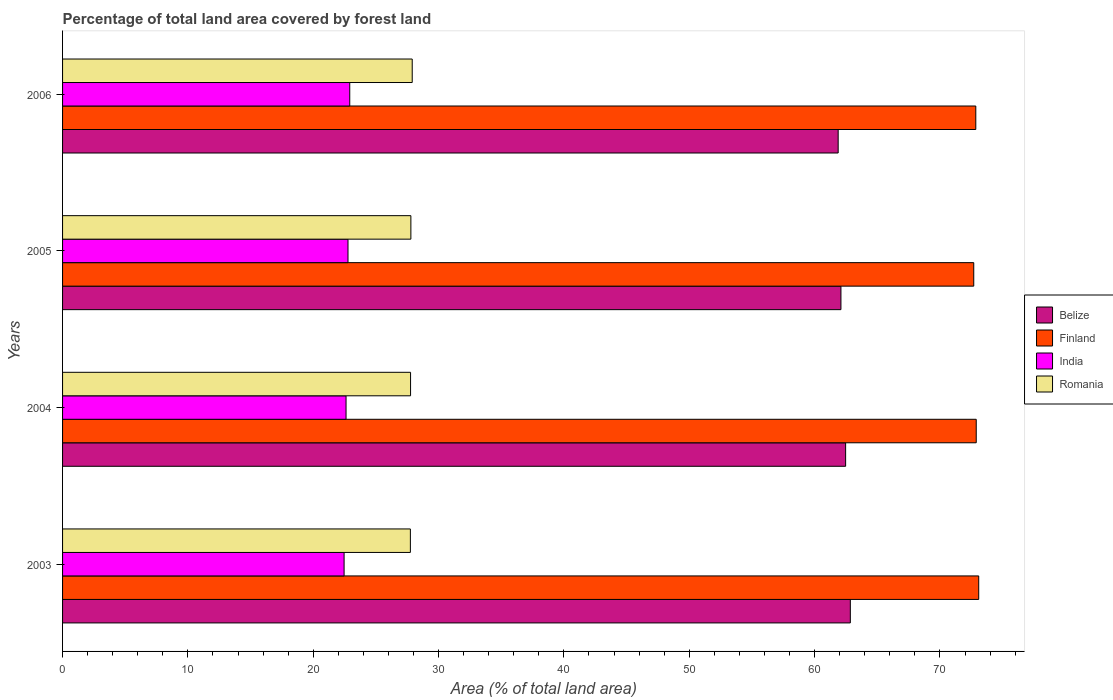How many different coloured bars are there?
Your answer should be very brief. 4. How many groups of bars are there?
Keep it short and to the point. 4. How many bars are there on the 3rd tick from the top?
Offer a very short reply. 4. In how many cases, is the number of bars for a given year not equal to the number of legend labels?
Provide a short and direct response. 0. What is the percentage of forest land in Romania in 2003?
Make the answer very short. 27.75. Across all years, what is the maximum percentage of forest land in Finland?
Ensure brevity in your answer.  73.09. Across all years, what is the minimum percentage of forest land in India?
Your answer should be very brief. 22.46. In which year was the percentage of forest land in Finland maximum?
Your answer should be compact. 2003. What is the total percentage of forest land in Finland in the graph?
Offer a very short reply. 291.55. What is the difference between the percentage of forest land in Finland in 2003 and that in 2005?
Keep it short and to the point. 0.4. What is the difference between the percentage of forest land in India in 2005 and the percentage of forest land in Belize in 2003?
Offer a very short reply. -40.08. What is the average percentage of forest land in Romania per year?
Give a very brief answer. 27.8. In the year 2005, what is the difference between the percentage of forest land in Finland and percentage of forest land in Belize?
Provide a short and direct response. 10.6. In how many years, is the percentage of forest land in Romania greater than 48 %?
Your answer should be compact. 0. What is the ratio of the percentage of forest land in India in 2003 to that in 2006?
Your answer should be very brief. 0.98. Is the difference between the percentage of forest land in Finland in 2003 and 2004 greater than the difference between the percentage of forest land in Belize in 2003 and 2004?
Give a very brief answer. No. What is the difference between the highest and the second highest percentage of forest land in Finland?
Offer a very short reply. 0.2. What is the difference between the highest and the lowest percentage of forest land in Finland?
Keep it short and to the point. 0.4. Is it the case that in every year, the sum of the percentage of forest land in Romania and percentage of forest land in India is greater than the sum of percentage of forest land in Belize and percentage of forest land in Finland?
Provide a succinct answer. No. What does the 4th bar from the top in 2005 represents?
Your response must be concise. Belize. What does the 3rd bar from the bottom in 2005 represents?
Your response must be concise. India. What is the difference between two consecutive major ticks on the X-axis?
Your answer should be compact. 10. Does the graph contain any zero values?
Give a very brief answer. No. Where does the legend appear in the graph?
Your answer should be compact. Center right. How many legend labels are there?
Make the answer very short. 4. How are the legend labels stacked?
Make the answer very short. Vertical. What is the title of the graph?
Provide a short and direct response. Percentage of total land area covered by forest land. What is the label or title of the X-axis?
Keep it short and to the point. Area (% of total land area). What is the Area (% of total land area) of Belize in 2003?
Offer a very short reply. 62.85. What is the Area (% of total land area) in Finland in 2003?
Make the answer very short. 73.09. What is the Area (% of total land area) of India in 2003?
Keep it short and to the point. 22.46. What is the Area (% of total land area) in Romania in 2003?
Give a very brief answer. 27.75. What is the Area (% of total land area) of Belize in 2004?
Provide a short and direct response. 62.48. What is the Area (% of total land area) in Finland in 2004?
Provide a short and direct response. 72.9. What is the Area (% of total land area) in India in 2004?
Offer a very short reply. 22.62. What is the Area (% of total land area) of Romania in 2004?
Provide a succinct answer. 27.77. What is the Area (% of total land area) in Belize in 2005?
Make the answer very short. 62.1. What is the Area (% of total land area) in Finland in 2005?
Make the answer very short. 72.7. What is the Area (% of total land area) in India in 2005?
Keep it short and to the point. 22.77. What is the Area (% of total land area) in Romania in 2005?
Provide a succinct answer. 27.79. What is the Area (% of total land area) of Belize in 2006?
Provide a short and direct response. 61.88. What is the Area (% of total land area) of Finland in 2006?
Ensure brevity in your answer.  72.86. What is the Area (% of total land area) in India in 2006?
Make the answer very short. 22.91. What is the Area (% of total land area) of Romania in 2006?
Your response must be concise. 27.9. Across all years, what is the maximum Area (% of total land area) in Belize?
Your answer should be compact. 62.85. Across all years, what is the maximum Area (% of total land area) in Finland?
Offer a very short reply. 73.09. Across all years, what is the maximum Area (% of total land area) of India?
Ensure brevity in your answer.  22.91. Across all years, what is the maximum Area (% of total land area) of Romania?
Ensure brevity in your answer.  27.9. Across all years, what is the minimum Area (% of total land area) of Belize?
Offer a very short reply. 61.88. Across all years, what is the minimum Area (% of total land area) of Finland?
Make the answer very short. 72.7. Across all years, what is the minimum Area (% of total land area) of India?
Provide a succinct answer. 22.46. Across all years, what is the minimum Area (% of total land area) in Romania?
Ensure brevity in your answer.  27.75. What is the total Area (% of total land area) in Belize in the graph?
Your response must be concise. 249.31. What is the total Area (% of total land area) of Finland in the graph?
Your answer should be very brief. 291.55. What is the total Area (% of total land area) of India in the graph?
Your response must be concise. 90.76. What is the total Area (% of total land area) of Romania in the graph?
Provide a short and direct response. 111.2. What is the difference between the Area (% of total land area) in Belize in 2003 and that in 2004?
Give a very brief answer. 0.38. What is the difference between the Area (% of total land area) of Finland in 2003 and that in 2004?
Provide a succinct answer. 0.2. What is the difference between the Area (% of total land area) of India in 2003 and that in 2004?
Provide a succinct answer. -0.16. What is the difference between the Area (% of total land area) of Romania in 2003 and that in 2004?
Your answer should be compact. -0.02. What is the difference between the Area (% of total land area) of Belize in 2003 and that in 2005?
Provide a short and direct response. 0.75. What is the difference between the Area (% of total land area) in Finland in 2003 and that in 2005?
Make the answer very short. 0.4. What is the difference between the Area (% of total land area) of India in 2003 and that in 2005?
Offer a terse response. -0.31. What is the difference between the Area (% of total land area) of Romania in 2003 and that in 2005?
Keep it short and to the point. -0.04. What is the difference between the Area (% of total land area) in Belize in 2003 and that in 2006?
Provide a succinct answer. 0.97. What is the difference between the Area (% of total land area) of Finland in 2003 and that in 2006?
Your answer should be very brief. 0.23. What is the difference between the Area (% of total land area) of India in 2003 and that in 2006?
Make the answer very short. -0.45. What is the difference between the Area (% of total land area) of Romania in 2003 and that in 2006?
Your response must be concise. -0.15. What is the difference between the Area (% of total land area) of Belize in 2004 and that in 2005?
Provide a short and direct response. 0.37. What is the difference between the Area (% of total land area) of Finland in 2004 and that in 2005?
Provide a short and direct response. 0.2. What is the difference between the Area (% of total land area) in India in 2004 and that in 2005?
Offer a very short reply. -0.16. What is the difference between the Area (% of total land area) of Romania in 2004 and that in 2005?
Ensure brevity in your answer.  -0.02. What is the difference between the Area (% of total land area) in Belize in 2004 and that in 2006?
Your answer should be compact. 0.6. What is the difference between the Area (% of total land area) in Finland in 2004 and that in 2006?
Your answer should be compact. 0.03. What is the difference between the Area (% of total land area) in India in 2004 and that in 2006?
Give a very brief answer. -0.3. What is the difference between the Area (% of total land area) in Romania in 2004 and that in 2006?
Your answer should be compact. -0.13. What is the difference between the Area (% of total land area) of Belize in 2005 and that in 2006?
Your answer should be very brief. 0.22. What is the difference between the Area (% of total land area) in Finland in 2005 and that in 2006?
Make the answer very short. -0.16. What is the difference between the Area (% of total land area) of India in 2005 and that in 2006?
Give a very brief answer. -0.14. What is the difference between the Area (% of total land area) in Romania in 2005 and that in 2006?
Give a very brief answer. -0.11. What is the difference between the Area (% of total land area) of Belize in 2003 and the Area (% of total land area) of Finland in 2004?
Ensure brevity in your answer.  -10.04. What is the difference between the Area (% of total land area) in Belize in 2003 and the Area (% of total land area) in India in 2004?
Offer a terse response. 40.23. What is the difference between the Area (% of total land area) of Belize in 2003 and the Area (% of total land area) of Romania in 2004?
Offer a very short reply. 35.09. What is the difference between the Area (% of total land area) in Finland in 2003 and the Area (% of total land area) in India in 2004?
Offer a very short reply. 50.48. What is the difference between the Area (% of total land area) of Finland in 2003 and the Area (% of total land area) of Romania in 2004?
Offer a very short reply. 45.33. What is the difference between the Area (% of total land area) in India in 2003 and the Area (% of total land area) in Romania in 2004?
Offer a very short reply. -5.3. What is the difference between the Area (% of total land area) in Belize in 2003 and the Area (% of total land area) in Finland in 2005?
Keep it short and to the point. -9.85. What is the difference between the Area (% of total land area) in Belize in 2003 and the Area (% of total land area) in India in 2005?
Your answer should be very brief. 40.08. What is the difference between the Area (% of total land area) in Belize in 2003 and the Area (% of total land area) in Romania in 2005?
Your response must be concise. 35.06. What is the difference between the Area (% of total land area) of Finland in 2003 and the Area (% of total land area) of India in 2005?
Your answer should be very brief. 50.32. What is the difference between the Area (% of total land area) in Finland in 2003 and the Area (% of total land area) in Romania in 2005?
Give a very brief answer. 45.3. What is the difference between the Area (% of total land area) in India in 2003 and the Area (% of total land area) in Romania in 2005?
Your answer should be very brief. -5.33. What is the difference between the Area (% of total land area) in Belize in 2003 and the Area (% of total land area) in Finland in 2006?
Provide a succinct answer. -10.01. What is the difference between the Area (% of total land area) of Belize in 2003 and the Area (% of total land area) of India in 2006?
Provide a succinct answer. 39.94. What is the difference between the Area (% of total land area) in Belize in 2003 and the Area (% of total land area) in Romania in 2006?
Make the answer very short. 34.95. What is the difference between the Area (% of total land area) in Finland in 2003 and the Area (% of total land area) in India in 2006?
Your answer should be very brief. 50.18. What is the difference between the Area (% of total land area) of Finland in 2003 and the Area (% of total land area) of Romania in 2006?
Provide a succinct answer. 45.2. What is the difference between the Area (% of total land area) in India in 2003 and the Area (% of total land area) in Romania in 2006?
Your response must be concise. -5.44. What is the difference between the Area (% of total land area) of Belize in 2004 and the Area (% of total land area) of Finland in 2005?
Offer a very short reply. -10.22. What is the difference between the Area (% of total land area) of Belize in 2004 and the Area (% of total land area) of India in 2005?
Offer a terse response. 39.7. What is the difference between the Area (% of total land area) of Belize in 2004 and the Area (% of total land area) of Romania in 2005?
Provide a succinct answer. 34.69. What is the difference between the Area (% of total land area) in Finland in 2004 and the Area (% of total land area) in India in 2005?
Ensure brevity in your answer.  50.12. What is the difference between the Area (% of total land area) of Finland in 2004 and the Area (% of total land area) of Romania in 2005?
Give a very brief answer. 45.11. What is the difference between the Area (% of total land area) of India in 2004 and the Area (% of total land area) of Romania in 2005?
Keep it short and to the point. -5.17. What is the difference between the Area (% of total land area) in Belize in 2004 and the Area (% of total land area) in Finland in 2006?
Your answer should be compact. -10.39. What is the difference between the Area (% of total land area) in Belize in 2004 and the Area (% of total land area) in India in 2006?
Your answer should be compact. 39.56. What is the difference between the Area (% of total land area) in Belize in 2004 and the Area (% of total land area) in Romania in 2006?
Provide a succinct answer. 34.58. What is the difference between the Area (% of total land area) of Finland in 2004 and the Area (% of total land area) of India in 2006?
Keep it short and to the point. 49.98. What is the difference between the Area (% of total land area) of Finland in 2004 and the Area (% of total land area) of Romania in 2006?
Offer a terse response. 45. What is the difference between the Area (% of total land area) in India in 2004 and the Area (% of total land area) in Romania in 2006?
Your answer should be compact. -5.28. What is the difference between the Area (% of total land area) in Belize in 2005 and the Area (% of total land area) in Finland in 2006?
Keep it short and to the point. -10.76. What is the difference between the Area (% of total land area) of Belize in 2005 and the Area (% of total land area) of India in 2006?
Your answer should be compact. 39.19. What is the difference between the Area (% of total land area) of Belize in 2005 and the Area (% of total land area) of Romania in 2006?
Your answer should be very brief. 34.2. What is the difference between the Area (% of total land area) in Finland in 2005 and the Area (% of total land area) in India in 2006?
Give a very brief answer. 49.78. What is the difference between the Area (% of total land area) in Finland in 2005 and the Area (% of total land area) in Romania in 2006?
Your answer should be very brief. 44.8. What is the difference between the Area (% of total land area) in India in 2005 and the Area (% of total land area) in Romania in 2006?
Give a very brief answer. -5.12. What is the average Area (% of total land area) in Belize per year?
Your answer should be very brief. 62.33. What is the average Area (% of total land area) of Finland per year?
Your answer should be compact. 72.89. What is the average Area (% of total land area) in India per year?
Your answer should be compact. 22.69. What is the average Area (% of total land area) in Romania per year?
Provide a short and direct response. 27.8. In the year 2003, what is the difference between the Area (% of total land area) of Belize and Area (% of total land area) of Finland?
Offer a terse response. -10.24. In the year 2003, what is the difference between the Area (% of total land area) in Belize and Area (% of total land area) in India?
Your response must be concise. 40.39. In the year 2003, what is the difference between the Area (% of total land area) of Belize and Area (% of total land area) of Romania?
Your response must be concise. 35.1. In the year 2003, what is the difference between the Area (% of total land area) in Finland and Area (% of total land area) in India?
Give a very brief answer. 50.63. In the year 2003, what is the difference between the Area (% of total land area) in Finland and Area (% of total land area) in Romania?
Give a very brief answer. 45.34. In the year 2003, what is the difference between the Area (% of total land area) in India and Area (% of total land area) in Romania?
Your response must be concise. -5.29. In the year 2004, what is the difference between the Area (% of total land area) of Belize and Area (% of total land area) of Finland?
Provide a short and direct response. -10.42. In the year 2004, what is the difference between the Area (% of total land area) of Belize and Area (% of total land area) of India?
Provide a short and direct response. 39.86. In the year 2004, what is the difference between the Area (% of total land area) of Belize and Area (% of total land area) of Romania?
Provide a short and direct response. 34.71. In the year 2004, what is the difference between the Area (% of total land area) of Finland and Area (% of total land area) of India?
Provide a short and direct response. 50.28. In the year 2004, what is the difference between the Area (% of total land area) in Finland and Area (% of total land area) in Romania?
Make the answer very short. 45.13. In the year 2004, what is the difference between the Area (% of total land area) of India and Area (% of total land area) of Romania?
Offer a very short reply. -5.15. In the year 2005, what is the difference between the Area (% of total land area) in Belize and Area (% of total land area) in Finland?
Provide a succinct answer. -10.6. In the year 2005, what is the difference between the Area (% of total land area) in Belize and Area (% of total land area) in India?
Your answer should be compact. 39.33. In the year 2005, what is the difference between the Area (% of total land area) of Belize and Area (% of total land area) of Romania?
Your response must be concise. 34.31. In the year 2005, what is the difference between the Area (% of total land area) in Finland and Area (% of total land area) in India?
Give a very brief answer. 49.92. In the year 2005, what is the difference between the Area (% of total land area) of Finland and Area (% of total land area) of Romania?
Offer a terse response. 44.91. In the year 2005, what is the difference between the Area (% of total land area) of India and Area (% of total land area) of Romania?
Your answer should be very brief. -5.02. In the year 2006, what is the difference between the Area (% of total land area) in Belize and Area (% of total land area) in Finland?
Keep it short and to the point. -10.98. In the year 2006, what is the difference between the Area (% of total land area) in Belize and Area (% of total land area) in India?
Give a very brief answer. 38.97. In the year 2006, what is the difference between the Area (% of total land area) of Belize and Area (% of total land area) of Romania?
Make the answer very short. 33.98. In the year 2006, what is the difference between the Area (% of total land area) in Finland and Area (% of total land area) in India?
Offer a very short reply. 49.95. In the year 2006, what is the difference between the Area (% of total land area) of Finland and Area (% of total land area) of Romania?
Offer a very short reply. 44.96. In the year 2006, what is the difference between the Area (% of total land area) in India and Area (% of total land area) in Romania?
Offer a terse response. -4.98. What is the ratio of the Area (% of total land area) in Finland in 2003 to that in 2004?
Your answer should be compact. 1. What is the ratio of the Area (% of total land area) of Romania in 2003 to that in 2004?
Ensure brevity in your answer.  1. What is the ratio of the Area (% of total land area) in Belize in 2003 to that in 2005?
Your response must be concise. 1.01. What is the ratio of the Area (% of total land area) of Finland in 2003 to that in 2005?
Provide a succinct answer. 1.01. What is the ratio of the Area (% of total land area) of India in 2003 to that in 2005?
Provide a short and direct response. 0.99. What is the ratio of the Area (% of total land area) of Belize in 2003 to that in 2006?
Make the answer very short. 1.02. What is the ratio of the Area (% of total land area) in Finland in 2003 to that in 2006?
Offer a terse response. 1. What is the ratio of the Area (% of total land area) in India in 2003 to that in 2006?
Give a very brief answer. 0.98. What is the ratio of the Area (% of total land area) in India in 2004 to that in 2005?
Ensure brevity in your answer.  0.99. What is the ratio of the Area (% of total land area) in Belize in 2004 to that in 2006?
Offer a terse response. 1.01. What is the ratio of the Area (% of total land area) of Finland in 2004 to that in 2006?
Provide a succinct answer. 1. What is the ratio of the Area (% of total land area) of India in 2004 to that in 2006?
Your response must be concise. 0.99. What is the ratio of the Area (% of total land area) of Romania in 2004 to that in 2006?
Your answer should be compact. 1. What is the ratio of the Area (% of total land area) in Finland in 2005 to that in 2006?
Provide a short and direct response. 1. What is the ratio of the Area (% of total land area) of Romania in 2005 to that in 2006?
Your response must be concise. 1. What is the difference between the highest and the second highest Area (% of total land area) of Belize?
Your answer should be compact. 0.38. What is the difference between the highest and the second highest Area (% of total land area) of Finland?
Make the answer very short. 0.2. What is the difference between the highest and the second highest Area (% of total land area) in India?
Offer a terse response. 0.14. What is the difference between the highest and the second highest Area (% of total land area) in Romania?
Make the answer very short. 0.11. What is the difference between the highest and the lowest Area (% of total land area) of Belize?
Your answer should be very brief. 0.97. What is the difference between the highest and the lowest Area (% of total land area) in Finland?
Offer a very short reply. 0.4. What is the difference between the highest and the lowest Area (% of total land area) of India?
Make the answer very short. 0.45. What is the difference between the highest and the lowest Area (% of total land area) of Romania?
Keep it short and to the point. 0.15. 